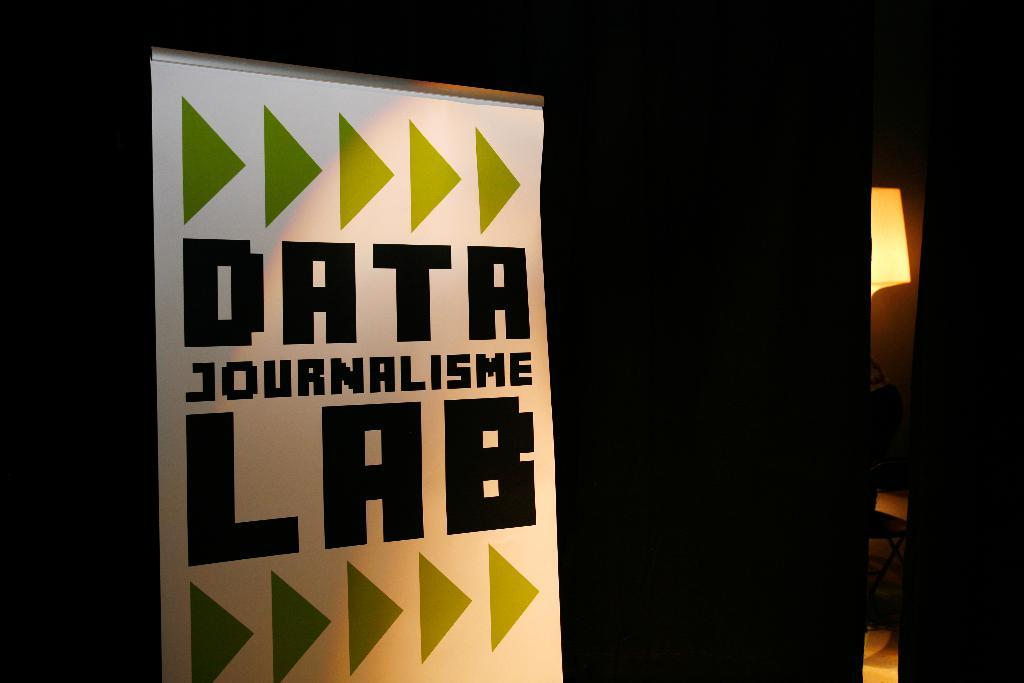<image>
Share a concise interpretation of the image provided. a poster that has the word Data at the top 